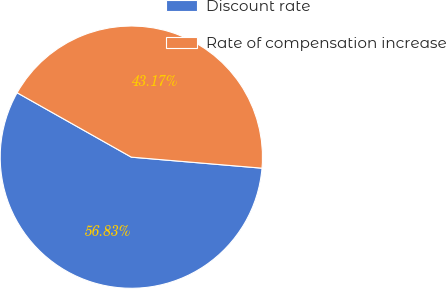<chart> <loc_0><loc_0><loc_500><loc_500><pie_chart><fcel>Discount rate<fcel>Rate of compensation increase<nl><fcel>56.83%<fcel>43.17%<nl></chart> 